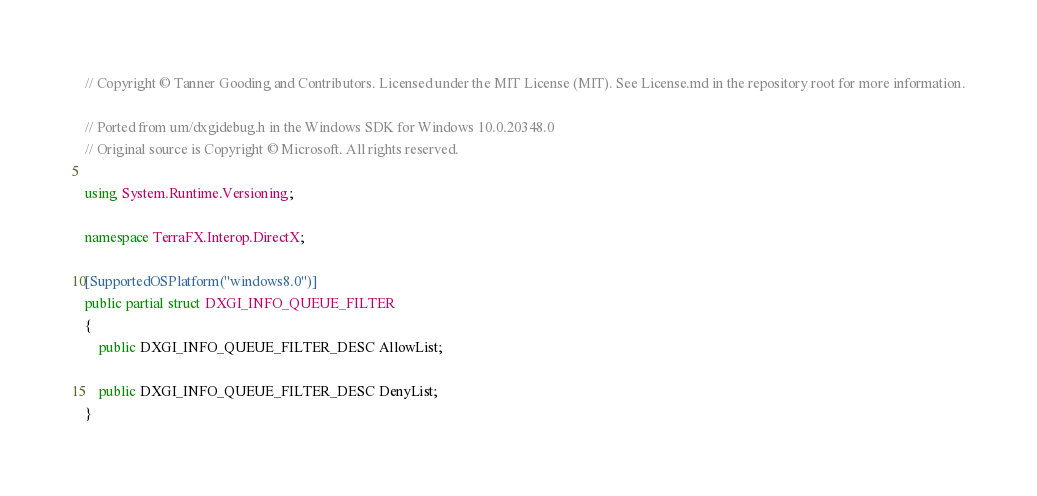Convert code to text. <code><loc_0><loc_0><loc_500><loc_500><_C#_>// Copyright © Tanner Gooding and Contributors. Licensed under the MIT License (MIT). See License.md in the repository root for more information.

// Ported from um/dxgidebug.h in the Windows SDK for Windows 10.0.20348.0
// Original source is Copyright © Microsoft. All rights reserved.

using System.Runtime.Versioning;

namespace TerraFX.Interop.DirectX;

[SupportedOSPlatform("windows8.0")]
public partial struct DXGI_INFO_QUEUE_FILTER
{
    public DXGI_INFO_QUEUE_FILTER_DESC AllowList;

    public DXGI_INFO_QUEUE_FILTER_DESC DenyList;
}
</code> 